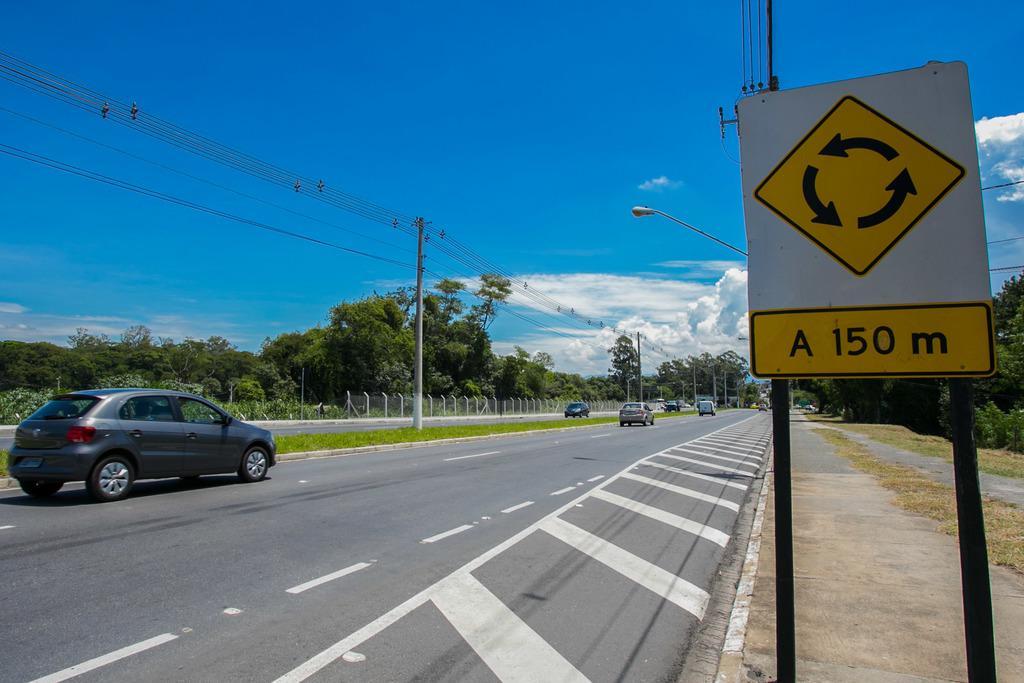Describe this image in one or two sentences. In this picture we can see the view of the road. In front we can see some cars moving on the road. Behind we can see electric poles and cables. In the background there are some trees. On the right corner there is a yellow and white caution board. On the top we can see the sky and clouds. 